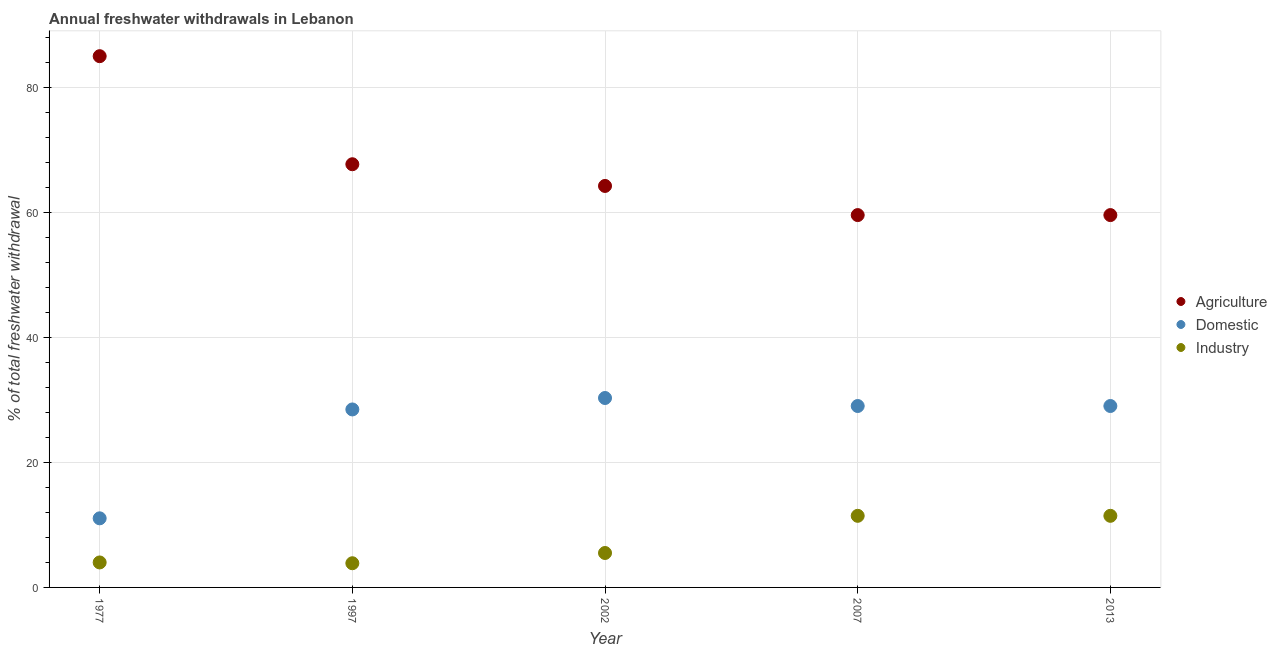How many different coloured dotlines are there?
Your response must be concise. 3. What is the percentage of freshwater withdrawal for industry in 1977?
Your response must be concise. 4. Across all years, what is the maximum percentage of freshwater withdrawal for domestic purposes?
Offer a very short reply. 30.29. Across all years, what is the minimum percentage of freshwater withdrawal for domestic purposes?
Provide a short and direct response. 11.05. In which year was the percentage of freshwater withdrawal for agriculture maximum?
Your answer should be compact. 1977. In which year was the percentage of freshwater withdrawal for industry minimum?
Your response must be concise. 1997. What is the total percentage of freshwater withdrawal for domestic purposes in the graph?
Keep it short and to the point. 127.82. What is the difference between the percentage of freshwater withdrawal for agriculture in 1997 and that in 2002?
Make the answer very short. 3.47. What is the difference between the percentage of freshwater withdrawal for domestic purposes in 1977 and the percentage of freshwater withdrawal for industry in 2013?
Give a very brief answer. -0.4. What is the average percentage of freshwater withdrawal for industry per year?
Provide a succinct answer. 7.25. In the year 2002, what is the difference between the percentage of freshwater withdrawal for industry and percentage of freshwater withdrawal for agriculture?
Your answer should be compact. -58.69. What is the ratio of the percentage of freshwater withdrawal for industry in 1977 to that in 2013?
Your answer should be compact. 0.35. What is the difference between the highest and the second highest percentage of freshwater withdrawal for industry?
Offer a terse response. 0. What is the difference between the highest and the lowest percentage of freshwater withdrawal for industry?
Your response must be concise. 7.58. In how many years, is the percentage of freshwater withdrawal for industry greater than the average percentage of freshwater withdrawal for industry taken over all years?
Make the answer very short. 2. Is the sum of the percentage of freshwater withdrawal for industry in 1997 and 2007 greater than the maximum percentage of freshwater withdrawal for agriculture across all years?
Make the answer very short. No. Is it the case that in every year, the sum of the percentage of freshwater withdrawal for agriculture and percentage of freshwater withdrawal for domestic purposes is greater than the percentage of freshwater withdrawal for industry?
Your answer should be very brief. Yes. Does the percentage of freshwater withdrawal for domestic purposes monotonically increase over the years?
Your answer should be very brief. No. Is the percentage of freshwater withdrawal for industry strictly greater than the percentage of freshwater withdrawal for domestic purposes over the years?
Ensure brevity in your answer.  No. Is the percentage of freshwater withdrawal for industry strictly less than the percentage of freshwater withdrawal for domestic purposes over the years?
Keep it short and to the point. Yes. How many years are there in the graph?
Provide a short and direct response. 5. What is the difference between two consecutive major ticks on the Y-axis?
Your answer should be very brief. 20. Are the values on the major ticks of Y-axis written in scientific E-notation?
Give a very brief answer. No. Does the graph contain any zero values?
Your answer should be very brief. No. Does the graph contain grids?
Offer a very short reply. Yes. How many legend labels are there?
Ensure brevity in your answer.  3. What is the title of the graph?
Give a very brief answer. Annual freshwater withdrawals in Lebanon. What is the label or title of the X-axis?
Offer a terse response. Year. What is the label or title of the Y-axis?
Keep it short and to the point. % of total freshwater withdrawal. What is the % of total freshwater withdrawal in Agriculture in 1977?
Your answer should be very brief. 84.95. What is the % of total freshwater withdrawal in Domestic in 1977?
Make the answer very short. 11.05. What is the % of total freshwater withdrawal in Industry in 1977?
Your response must be concise. 4. What is the % of total freshwater withdrawal in Agriculture in 1997?
Keep it short and to the point. 67.67. What is the % of total freshwater withdrawal of Domestic in 1997?
Ensure brevity in your answer.  28.46. What is the % of total freshwater withdrawal in Industry in 1997?
Make the answer very short. 3.87. What is the % of total freshwater withdrawal in Agriculture in 2002?
Give a very brief answer. 64.2. What is the % of total freshwater withdrawal of Domestic in 2002?
Offer a terse response. 30.29. What is the % of total freshwater withdrawal in Industry in 2002?
Provide a short and direct response. 5.51. What is the % of total freshwater withdrawal in Agriculture in 2007?
Your response must be concise. 59.54. What is the % of total freshwater withdrawal in Domestic in 2007?
Ensure brevity in your answer.  29.01. What is the % of total freshwater withdrawal in Industry in 2007?
Offer a very short reply. 11.45. What is the % of total freshwater withdrawal of Agriculture in 2013?
Keep it short and to the point. 59.54. What is the % of total freshwater withdrawal of Domestic in 2013?
Provide a short and direct response. 29.01. What is the % of total freshwater withdrawal of Industry in 2013?
Your answer should be compact. 11.45. Across all years, what is the maximum % of total freshwater withdrawal in Agriculture?
Your answer should be very brief. 84.95. Across all years, what is the maximum % of total freshwater withdrawal in Domestic?
Make the answer very short. 30.29. Across all years, what is the maximum % of total freshwater withdrawal in Industry?
Make the answer very short. 11.45. Across all years, what is the minimum % of total freshwater withdrawal of Agriculture?
Provide a succinct answer. 59.54. Across all years, what is the minimum % of total freshwater withdrawal in Domestic?
Offer a very short reply. 11.05. Across all years, what is the minimum % of total freshwater withdrawal in Industry?
Your answer should be very brief. 3.87. What is the total % of total freshwater withdrawal in Agriculture in the graph?
Your answer should be very brief. 335.9. What is the total % of total freshwater withdrawal of Domestic in the graph?
Your response must be concise. 127.82. What is the total % of total freshwater withdrawal in Industry in the graph?
Provide a short and direct response. 36.27. What is the difference between the % of total freshwater withdrawal of Agriculture in 1977 and that in 1997?
Ensure brevity in your answer.  17.28. What is the difference between the % of total freshwater withdrawal in Domestic in 1977 and that in 1997?
Provide a short and direct response. -17.41. What is the difference between the % of total freshwater withdrawal in Industry in 1977 and that in 1997?
Your answer should be compact. 0.13. What is the difference between the % of total freshwater withdrawal of Agriculture in 1977 and that in 2002?
Your answer should be very brief. 20.75. What is the difference between the % of total freshwater withdrawal of Domestic in 1977 and that in 2002?
Provide a short and direct response. -19.24. What is the difference between the % of total freshwater withdrawal in Industry in 1977 and that in 2002?
Ensure brevity in your answer.  -1.51. What is the difference between the % of total freshwater withdrawal of Agriculture in 1977 and that in 2007?
Make the answer very short. 25.41. What is the difference between the % of total freshwater withdrawal in Domestic in 1977 and that in 2007?
Make the answer very short. -17.96. What is the difference between the % of total freshwater withdrawal in Industry in 1977 and that in 2007?
Your answer should be very brief. -7.46. What is the difference between the % of total freshwater withdrawal of Agriculture in 1977 and that in 2013?
Give a very brief answer. 25.41. What is the difference between the % of total freshwater withdrawal in Domestic in 1977 and that in 2013?
Keep it short and to the point. -17.96. What is the difference between the % of total freshwater withdrawal in Industry in 1977 and that in 2013?
Give a very brief answer. -7.46. What is the difference between the % of total freshwater withdrawal of Agriculture in 1997 and that in 2002?
Your answer should be very brief. 3.47. What is the difference between the % of total freshwater withdrawal of Domestic in 1997 and that in 2002?
Offer a terse response. -1.83. What is the difference between the % of total freshwater withdrawal of Industry in 1997 and that in 2002?
Offer a very short reply. -1.64. What is the difference between the % of total freshwater withdrawal in Agriculture in 1997 and that in 2007?
Ensure brevity in your answer.  8.13. What is the difference between the % of total freshwater withdrawal in Domestic in 1997 and that in 2007?
Offer a very short reply. -0.55. What is the difference between the % of total freshwater withdrawal in Industry in 1997 and that in 2007?
Keep it short and to the point. -7.58. What is the difference between the % of total freshwater withdrawal in Agriculture in 1997 and that in 2013?
Provide a short and direct response. 8.13. What is the difference between the % of total freshwater withdrawal in Domestic in 1997 and that in 2013?
Provide a short and direct response. -0.55. What is the difference between the % of total freshwater withdrawal of Industry in 1997 and that in 2013?
Provide a succinct answer. -7.58. What is the difference between the % of total freshwater withdrawal of Agriculture in 2002 and that in 2007?
Ensure brevity in your answer.  4.66. What is the difference between the % of total freshwater withdrawal of Domestic in 2002 and that in 2007?
Ensure brevity in your answer.  1.28. What is the difference between the % of total freshwater withdrawal in Industry in 2002 and that in 2007?
Provide a succinct answer. -5.94. What is the difference between the % of total freshwater withdrawal in Agriculture in 2002 and that in 2013?
Provide a succinct answer. 4.66. What is the difference between the % of total freshwater withdrawal in Domestic in 2002 and that in 2013?
Give a very brief answer. 1.28. What is the difference between the % of total freshwater withdrawal in Industry in 2002 and that in 2013?
Offer a very short reply. -5.94. What is the difference between the % of total freshwater withdrawal of Agriculture in 2007 and that in 2013?
Your response must be concise. 0. What is the difference between the % of total freshwater withdrawal of Industry in 2007 and that in 2013?
Ensure brevity in your answer.  0. What is the difference between the % of total freshwater withdrawal of Agriculture in 1977 and the % of total freshwater withdrawal of Domestic in 1997?
Offer a very short reply. 56.49. What is the difference between the % of total freshwater withdrawal of Agriculture in 1977 and the % of total freshwater withdrawal of Industry in 1997?
Provide a succinct answer. 81.08. What is the difference between the % of total freshwater withdrawal of Domestic in 1977 and the % of total freshwater withdrawal of Industry in 1997?
Provide a succinct answer. 7.18. What is the difference between the % of total freshwater withdrawal of Agriculture in 1977 and the % of total freshwater withdrawal of Domestic in 2002?
Your answer should be very brief. 54.66. What is the difference between the % of total freshwater withdrawal in Agriculture in 1977 and the % of total freshwater withdrawal in Industry in 2002?
Make the answer very short. 79.44. What is the difference between the % of total freshwater withdrawal of Domestic in 1977 and the % of total freshwater withdrawal of Industry in 2002?
Your answer should be very brief. 5.54. What is the difference between the % of total freshwater withdrawal in Agriculture in 1977 and the % of total freshwater withdrawal in Domestic in 2007?
Provide a succinct answer. 55.94. What is the difference between the % of total freshwater withdrawal in Agriculture in 1977 and the % of total freshwater withdrawal in Industry in 2007?
Provide a short and direct response. 73.5. What is the difference between the % of total freshwater withdrawal in Domestic in 1977 and the % of total freshwater withdrawal in Industry in 2007?
Provide a short and direct response. -0.4. What is the difference between the % of total freshwater withdrawal in Agriculture in 1977 and the % of total freshwater withdrawal in Domestic in 2013?
Make the answer very short. 55.94. What is the difference between the % of total freshwater withdrawal of Agriculture in 1977 and the % of total freshwater withdrawal of Industry in 2013?
Provide a short and direct response. 73.5. What is the difference between the % of total freshwater withdrawal in Domestic in 1977 and the % of total freshwater withdrawal in Industry in 2013?
Offer a very short reply. -0.4. What is the difference between the % of total freshwater withdrawal in Agriculture in 1997 and the % of total freshwater withdrawal in Domestic in 2002?
Offer a terse response. 37.38. What is the difference between the % of total freshwater withdrawal of Agriculture in 1997 and the % of total freshwater withdrawal of Industry in 2002?
Make the answer very short. 62.16. What is the difference between the % of total freshwater withdrawal in Domestic in 1997 and the % of total freshwater withdrawal in Industry in 2002?
Keep it short and to the point. 22.95. What is the difference between the % of total freshwater withdrawal of Agriculture in 1997 and the % of total freshwater withdrawal of Domestic in 2007?
Keep it short and to the point. 38.66. What is the difference between the % of total freshwater withdrawal in Agriculture in 1997 and the % of total freshwater withdrawal in Industry in 2007?
Keep it short and to the point. 56.22. What is the difference between the % of total freshwater withdrawal of Domestic in 1997 and the % of total freshwater withdrawal of Industry in 2007?
Provide a short and direct response. 17.01. What is the difference between the % of total freshwater withdrawal of Agriculture in 1997 and the % of total freshwater withdrawal of Domestic in 2013?
Provide a succinct answer. 38.66. What is the difference between the % of total freshwater withdrawal of Agriculture in 1997 and the % of total freshwater withdrawal of Industry in 2013?
Your answer should be very brief. 56.22. What is the difference between the % of total freshwater withdrawal in Domestic in 1997 and the % of total freshwater withdrawal in Industry in 2013?
Give a very brief answer. 17.01. What is the difference between the % of total freshwater withdrawal in Agriculture in 2002 and the % of total freshwater withdrawal in Domestic in 2007?
Provide a short and direct response. 35.19. What is the difference between the % of total freshwater withdrawal in Agriculture in 2002 and the % of total freshwater withdrawal in Industry in 2007?
Give a very brief answer. 52.75. What is the difference between the % of total freshwater withdrawal of Domestic in 2002 and the % of total freshwater withdrawal of Industry in 2007?
Your response must be concise. 18.84. What is the difference between the % of total freshwater withdrawal in Agriculture in 2002 and the % of total freshwater withdrawal in Domestic in 2013?
Ensure brevity in your answer.  35.19. What is the difference between the % of total freshwater withdrawal in Agriculture in 2002 and the % of total freshwater withdrawal in Industry in 2013?
Provide a short and direct response. 52.75. What is the difference between the % of total freshwater withdrawal in Domestic in 2002 and the % of total freshwater withdrawal in Industry in 2013?
Provide a succinct answer. 18.84. What is the difference between the % of total freshwater withdrawal of Agriculture in 2007 and the % of total freshwater withdrawal of Domestic in 2013?
Make the answer very short. 30.53. What is the difference between the % of total freshwater withdrawal in Agriculture in 2007 and the % of total freshwater withdrawal in Industry in 2013?
Ensure brevity in your answer.  48.09. What is the difference between the % of total freshwater withdrawal in Domestic in 2007 and the % of total freshwater withdrawal in Industry in 2013?
Keep it short and to the point. 17.56. What is the average % of total freshwater withdrawal of Agriculture per year?
Ensure brevity in your answer.  67.18. What is the average % of total freshwater withdrawal in Domestic per year?
Your answer should be compact. 25.56. What is the average % of total freshwater withdrawal of Industry per year?
Offer a terse response. 7.25. In the year 1977, what is the difference between the % of total freshwater withdrawal in Agriculture and % of total freshwater withdrawal in Domestic?
Provide a succinct answer. 73.9. In the year 1977, what is the difference between the % of total freshwater withdrawal of Agriculture and % of total freshwater withdrawal of Industry?
Keep it short and to the point. 80.95. In the year 1977, what is the difference between the % of total freshwater withdrawal in Domestic and % of total freshwater withdrawal in Industry?
Provide a succinct answer. 7.05. In the year 1997, what is the difference between the % of total freshwater withdrawal in Agriculture and % of total freshwater withdrawal in Domestic?
Offer a terse response. 39.21. In the year 1997, what is the difference between the % of total freshwater withdrawal of Agriculture and % of total freshwater withdrawal of Industry?
Your answer should be compact. 63.8. In the year 1997, what is the difference between the % of total freshwater withdrawal in Domestic and % of total freshwater withdrawal in Industry?
Your response must be concise. 24.59. In the year 2002, what is the difference between the % of total freshwater withdrawal in Agriculture and % of total freshwater withdrawal in Domestic?
Give a very brief answer. 33.91. In the year 2002, what is the difference between the % of total freshwater withdrawal in Agriculture and % of total freshwater withdrawal in Industry?
Your answer should be very brief. 58.69. In the year 2002, what is the difference between the % of total freshwater withdrawal of Domestic and % of total freshwater withdrawal of Industry?
Your answer should be very brief. 24.78. In the year 2007, what is the difference between the % of total freshwater withdrawal of Agriculture and % of total freshwater withdrawal of Domestic?
Offer a very short reply. 30.53. In the year 2007, what is the difference between the % of total freshwater withdrawal in Agriculture and % of total freshwater withdrawal in Industry?
Provide a succinct answer. 48.09. In the year 2007, what is the difference between the % of total freshwater withdrawal in Domestic and % of total freshwater withdrawal in Industry?
Your answer should be compact. 17.56. In the year 2013, what is the difference between the % of total freshwater withdrawal in Agriculture and % of total freshwater withdrawal in Domestic?
Your answer should be very brief. 30.53. In the year 2013, what is the difference between the % of total freshwater withdrawal of Agriculture and % of total freshwater withdrawal of Industry?
Give a very brief answer. 48.09. In the year 2013, what is the difference between the % of total freshwater withdrawal in Domestic and % of total freshwater withdrawal in Industry?
Provide a short and direct response. 17.56. What is the ratio of the % of total freshwater withdrawal of Agriculture in 1977 to that in 1997?
Keep it short and to the point. 1.26. What is the ratio of the % of total freshwater withdrawal in Domestic in 1977 to that in 1997?
Your answer should be very brief. 0.39. What is the ratio of the % of total freshwater withdrawal in Industry in 1977 to that in 1997?
Offer a terse response. 1.03. What is the ratio of the % of total freshwater withdrawal of Agriculture in 1977 to that in 2002?
Your response must be concise. 1.32. What is the ratio of the % of total freshwater withdrawal of Domestic in 1977 to that in 2002?
Your answer should be compact. 0.36. What is the ratio of the % of total freshwater withdrawal in Industry in 1977 to that in 2002?
Provide a succinct answer. 0.73. What is the ratio of the % of total freshwater withdrawal of Agriculture in 1977 to that in 2007?
Offer a terse response. 1.43. What is the ratio of the % of total freshwater withdrawal of Domestic in 1977 to that in 2007?
Your answer should be very brief. 0.38. What is the ratio of the % of total freshwater withdrawal of Industry in 1977 to that in 2007?
Your answer should be compact. 0.35. What is the ratio of the % of total freshwater withdrawal of Agriculture in 1977 to that in 2013?
Give a very brief answer. 1.43. What is the ratio of the % of total freshwater withdrawal of Domestic in 1977 to that in 2013?
Keep it short and to the point. 0.38. What is the ratio of the % of total freshwater withdrawal in Industry in 1977 to that in 2013?
Your answer should be very brief. 0.35. What is the ratio of the % of total freshwater withdrawal of Agriculture in 1997 to that in 2002?
Provide a short and direct response. 1.05. What is the ratio of the % of total freshwater withdrawal in Domestic in 1997 to that in 2002?
Offer a very short reply. 0.94. What is the ratio of the % of total freshwater withdrawal in Industry in 1997 to that in 2002?
Provide a short and direct response. 0.7. What is the ratio of the % of total freshwater withdrawal in Agriculture in 1997 to that in 2007?
Make the answer very short. 1.14. What is the ratio of the % of total freshwater withdrawal of Domestic in 1997 to that in 2007?
Give a very brief answer. 0.98. What is the ratio of the % of total freshwater withdrawal in Industry in 1997 to that in 2007?
Offer a very short reply. 0.34. What is the ratio of the % of total freshwater withdrawal of Agriculture in 1997 to that in 2013?
Offer a terse response. 1.14. What is the ratio of the % of total freshwater withdrawal in Industry in 1997 to that in 2013?
Your response must be concise. 0.34. What is the ratio of the % of total freshwater withdrawal in Agriculture in 2002 to that in 2007?
Make the answer very short. 1.08. What is the ratio of the % of total freshwater withdrawal in Domestic in 2002 to that in 2007?
Keep it short and to the point. 1.04. What is the ratio of the % of total freshwater withdrawal of Industry in 2002 to that in 2007?
Give a very brief answer. 0.48. What is the ratio of the % of total freshwater withdrawal in Agriculture in 2002 to that in 2013?
Keep it short and to the point. 1.08. What is the ratio of the % of total freshwater withdrawal of Domestic in 2002 to that in 2013?
Ensure brevity in your answer.  1.04. What is the ratio of the % of total freshwater withdrawal in Industry in 2002 to that in 2013?
Keep it short and to the point. 0.48. What is the ratio of the % of total freshwater withdrawal in Agriculture in 2007 to that in 2013?
Offer a terse response. 1. What is the ratio of the % of total freshwater withdrawal in Industry in 2007 to that in 2013?
Your answer should be compact. 1. What is the difference between the highest and the second highest % of total freshwater withdrawal in Agriculture?
Your answer should be compact. 17.28. What is the difference between the highest and the second highest % of total freshwater withdrawal of Domestic?
Make the answer very short. 1.28. What is the difference between the highest and the second highest % of total freshwater withdrawal of Industry?
Make the answer very short. 0. What is the difference between the highest and the lowest % of total freshwater withdrawal of Agriculture?
Give a very brief answer. 25.41. What is the difference between the highest and the lowest % of total freshwater withdrawal of Domestic?
Your response must be concise. 19.24. What is the difference between the highest and the lowest % of total freshwater withdrawal of Industry?
Offer a very short reply. 7.58. 